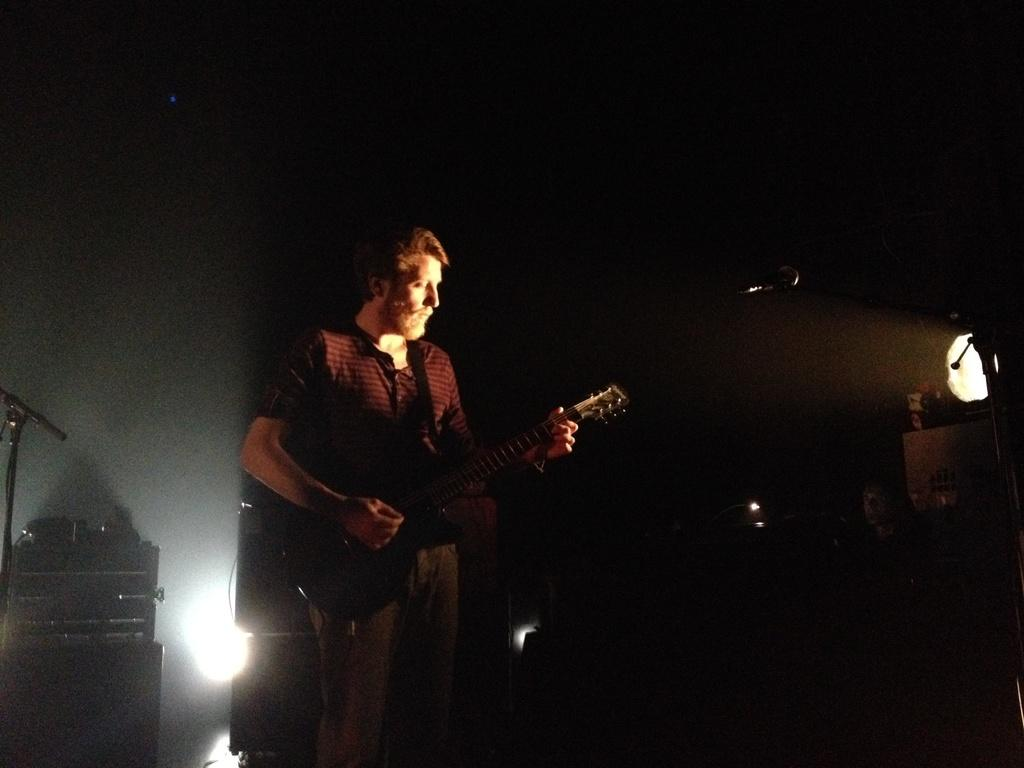What is the man in the image doing? The man is playing a guitar. What is the name of the man in the image? The man's name is Mike. Can you describe the lighting in the image? There is a light visible in the image. How many snakes can be seen wrapped around the guitar in the image? There are no snakes present in the image. What type of hammer is the man using to play the guitar in the image? There is no hammer present in the image, and the man is playing the guitar with his hands. 